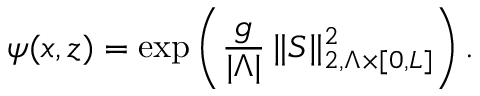Convert formula to latex. <formula><loc_0><loc_0><loc_500><loc_500>\psi ( x , z ) = \exp \left ( \frac { g } { | \Lambda | } \, \| S \| _ { 2 , \Lambda \times [ 0 , L ] } ^ { 2 } \right ) .</formula> 